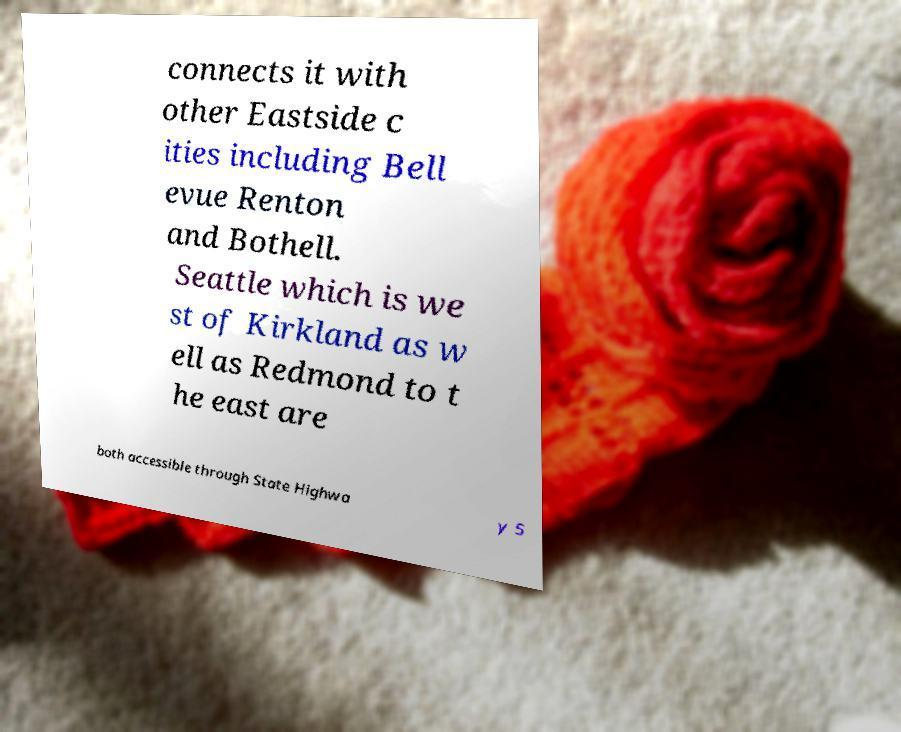There's text embedded in this image that I need extracted. Can you transcribe it verbatim? connects it with other Eastside c ities including Bell evue Renton and Bothell. Seattle which is we st of Kirkland as w ell as Redmond to t he east are both accessible through State Highwa y 5 